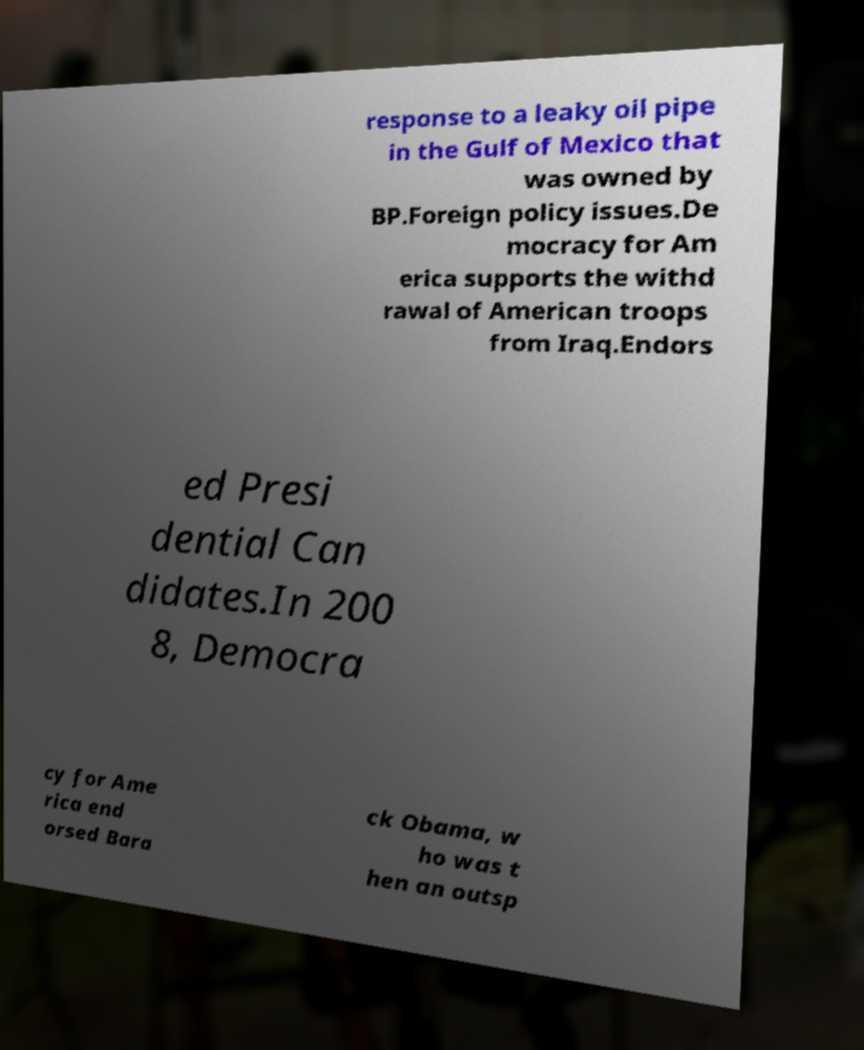Can you read and provide the text displayed in the image?This photo seems to have some interesting text. Can you extract and type it out for me? response to a leaky oil pipe in the Gulf of Mexico that was owned by BP.Foreign policy issues.De mocracy for Am erica supports the withd rawal of American troops from Iraq.Endors ed Presi dential Can didates.In 200 8, Democra cy for Ame rica end orsed Bara ck Obama, w ho was t hen an outsp 